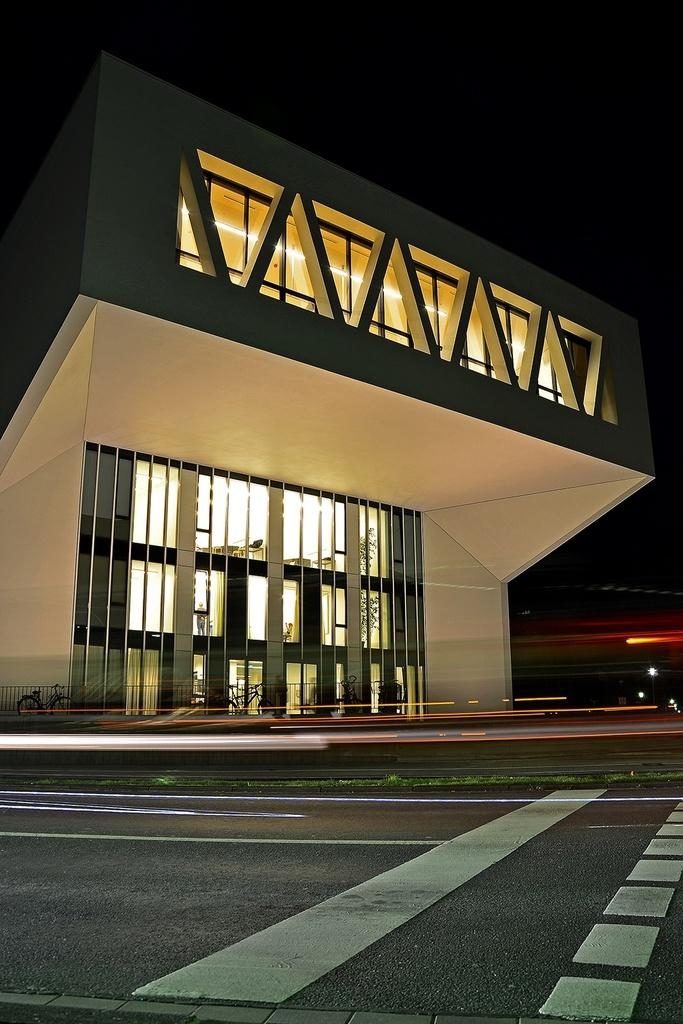What type of pathway is shown in the image? There is a road in the image. What structure can be seen near the road? There is a building in the image. What mode of transportation is visible in the image? Bicycles are visible in the image. What type of illumination is present in the image? Lights are present in the image. How would you describe the overall lighting in the image? The background of the image is dark. What type of industry is depicted in the image? There is no industry depicted in the image; it features a road, a building, bicycles, lights, and a dark background. How many chains are visible on the bicycles in the image? There is no mention of chains on the bicycles in the image, so we cannot determine the number of chains. 